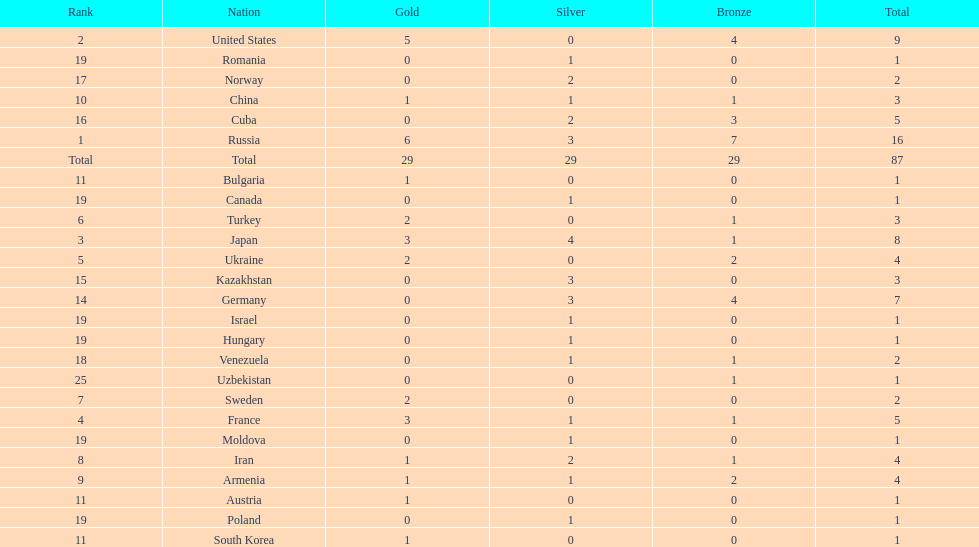How many combined gold medals did japan and france win? 6. 